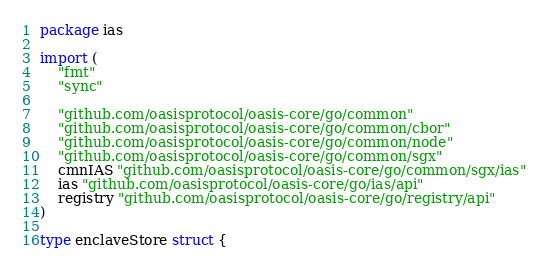Convert code to text. <code><loc_0><loc_0><loc_500><loc_500><_Go_>package ias

import (
	"fmt"
	"sync"

	"github.com/oasisprotocol/oasis-core/go/common"
	"github.com/oasisprotocol/oasis-core/go/common/cbor"
	"github.com/oasisprotocol/oasis-core/go/common/node"
	"github.com/oasisprotocol/oasis-core/go/common/sgx"
	cmnIAS "github.com/oasisprotocol/oasis-core/go/common/sgx/ias"
	ias "github.com/oasisprotocol/oasis-core/go/ias/api"
	registry "github.com/oasisprotocol/oasis-core/go/registry/api"
)

type enclaveStore struct {</code> 